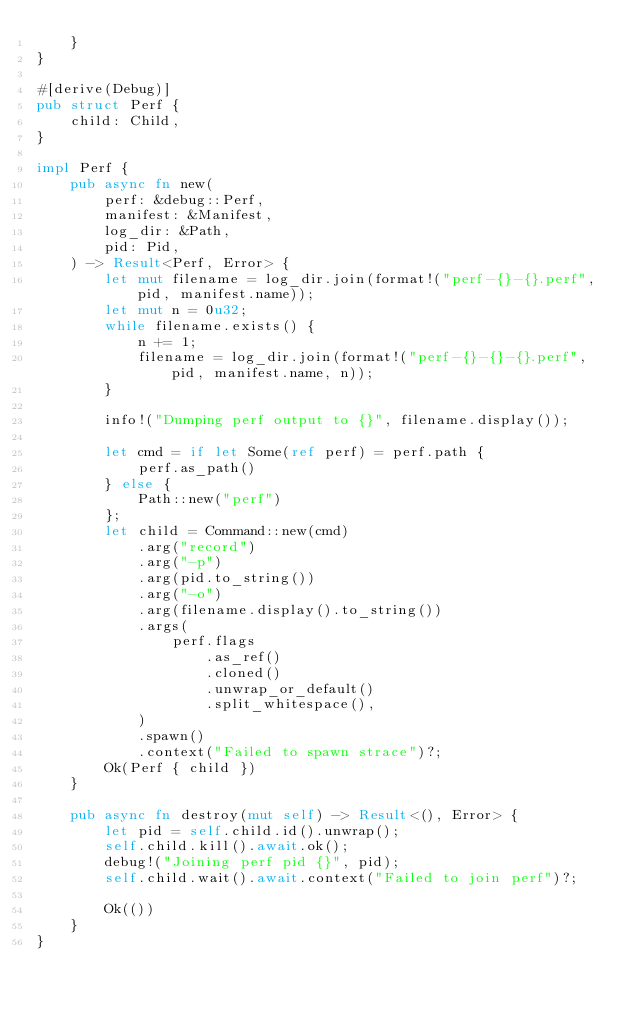<code> <loc_0><loc_0><loc_500><loc_500><_Rust_>    }
}

#[derive(Debug)]
pub struct Perf {
    child: Child,
}

impl Perf {
    pub async fn new(
        perf: &debug::Perf,
        manifest: &Manifest,
        log_dir: &Path,
        pid: Pid,
    ) -> Result<Perf, Error> {
        let mut filename = log_dir.join(format!("perf-{}-{}.perf", pid, manifest.name));
        let mut n = 0u32;
        while filename.exists() {
            n += 1;
            filename = log_dir.join(format!("perf-{}-{}-{}.perf", pid, manifest.name, n));
        }

        info!("Dumping perf output to {}", filename.display());

        let cmd = if let Some(ref perf) = perf.path {
            perf.as_path()
        } else {
            Path::new("perf")
        };
        let child = Command::new(cmd)
            .arg("record")
            .arg("-p")
            .arg(pid.to_string())
            .arg("-o")
            .arg(filename.display().to_string())
            .args(
                perf.flags
                    .as_ref()
                    .cloned()
                    .unwrap_or_default()
                    .split_whitespace(),
            )
            .spawn()
            .context("Failed to spawn strace")?;
        Ok(Perf { child })
    }

    pub async fn destroy(mut self) -> Result<(), Error> {
        let pid = self.child.id().unwrap();
        self.child.kill().await.ok();
        debug!("Joining perf pid {}", pid);
        self.child.wait().await.context("Failed to join perf")?;

        Ok(())
    }
}
</code> 